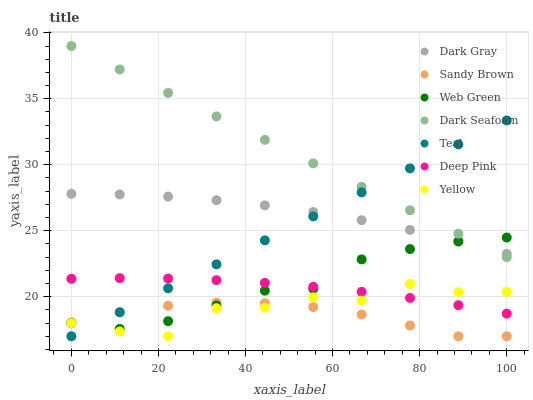Does Sandy Brown have the minimum area under the curve?
Answer yes or no. Yes. Does Dark Seafoam have the maximum area under the curve?
Answer yes or no. Yes. Does Web Green have the minimum area under the curve?
Answer yes or no. No. Does Web Green have the maximum area under the curve?
Answer yes or no. No. Is Teal the smoothest?
Answer yes or no. Yes. Is Yellow the roughest?
Answer yes or no. Yes. Is Web Green the smoothest?
Answer yes or no. No. Is Web Green the roughest?
Answer yes or no. No. Does Yellow have the lowest value?
Answer yes or no. Yes. Does Web Green have the lowest value?
Answer yes or no. No. Does Dark Seafoam have the highest value?
Answer yes or no. Yes. Does Web Green have the highest value?
Answer yes or no. No. Is Deep Pink less than Dark Seafoam?
Answer yes or no. Yes. Is Dark Seafoam greater than Deep Pink?
Answer yes or no. Yes. Does Web Green intersect Yellow?
Answer yes or no. Yes. Is Web Green less than Yellow?
Answer yes or no. No. Is Web Green greater than Yellow?
Answer yes or no. No. Does Deep Pink intersect Dark Seafoam?
Answer yes or no. No. 